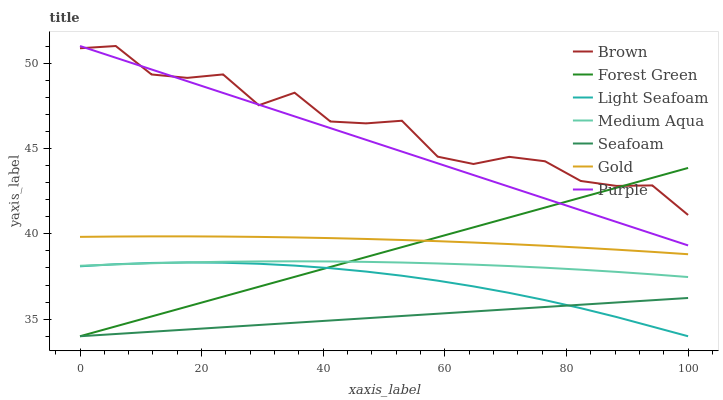Does Seafoam have the minimum area under the curve?
Answer yes or no. Yes. Does Brown have the maximum area under the curve?
Answer yes or no. Yes. Does Gold have the minimum area under the curve?
Answer yes or no. No. Does Gold have the maximum area under the curve?
Answer yes or no. No. Is Purple the smoothest?
Answer yes or no. Yes. Is Brown the roughest?
Answer yes or no. Yes. Is Gold the smoothest?
Answer yes or no. No. Is Gold the roughest?
Answer yes or no. No. Does Gold have the lowest value?
Answer yes or no. No. Does Purple have the highest value?
Answer yes or no. Yes. Does Gold have the highest value?
Answer yes or no. No. Is Light Seafoam less than Purple?
Answer yes or no. Yes. Is Gold greater than Medium Aqua?
Answer yes or no. Yes. Does Gold intersect Forest Green?
Answer yes or no. Yes. Is Gold less than Forest Green?
Answer yes or no. No. Is Gold greater than Forest Green?
Answer yes or no. No. Does Light Seafoam intersect Purple?
Answer yes or no. No. 